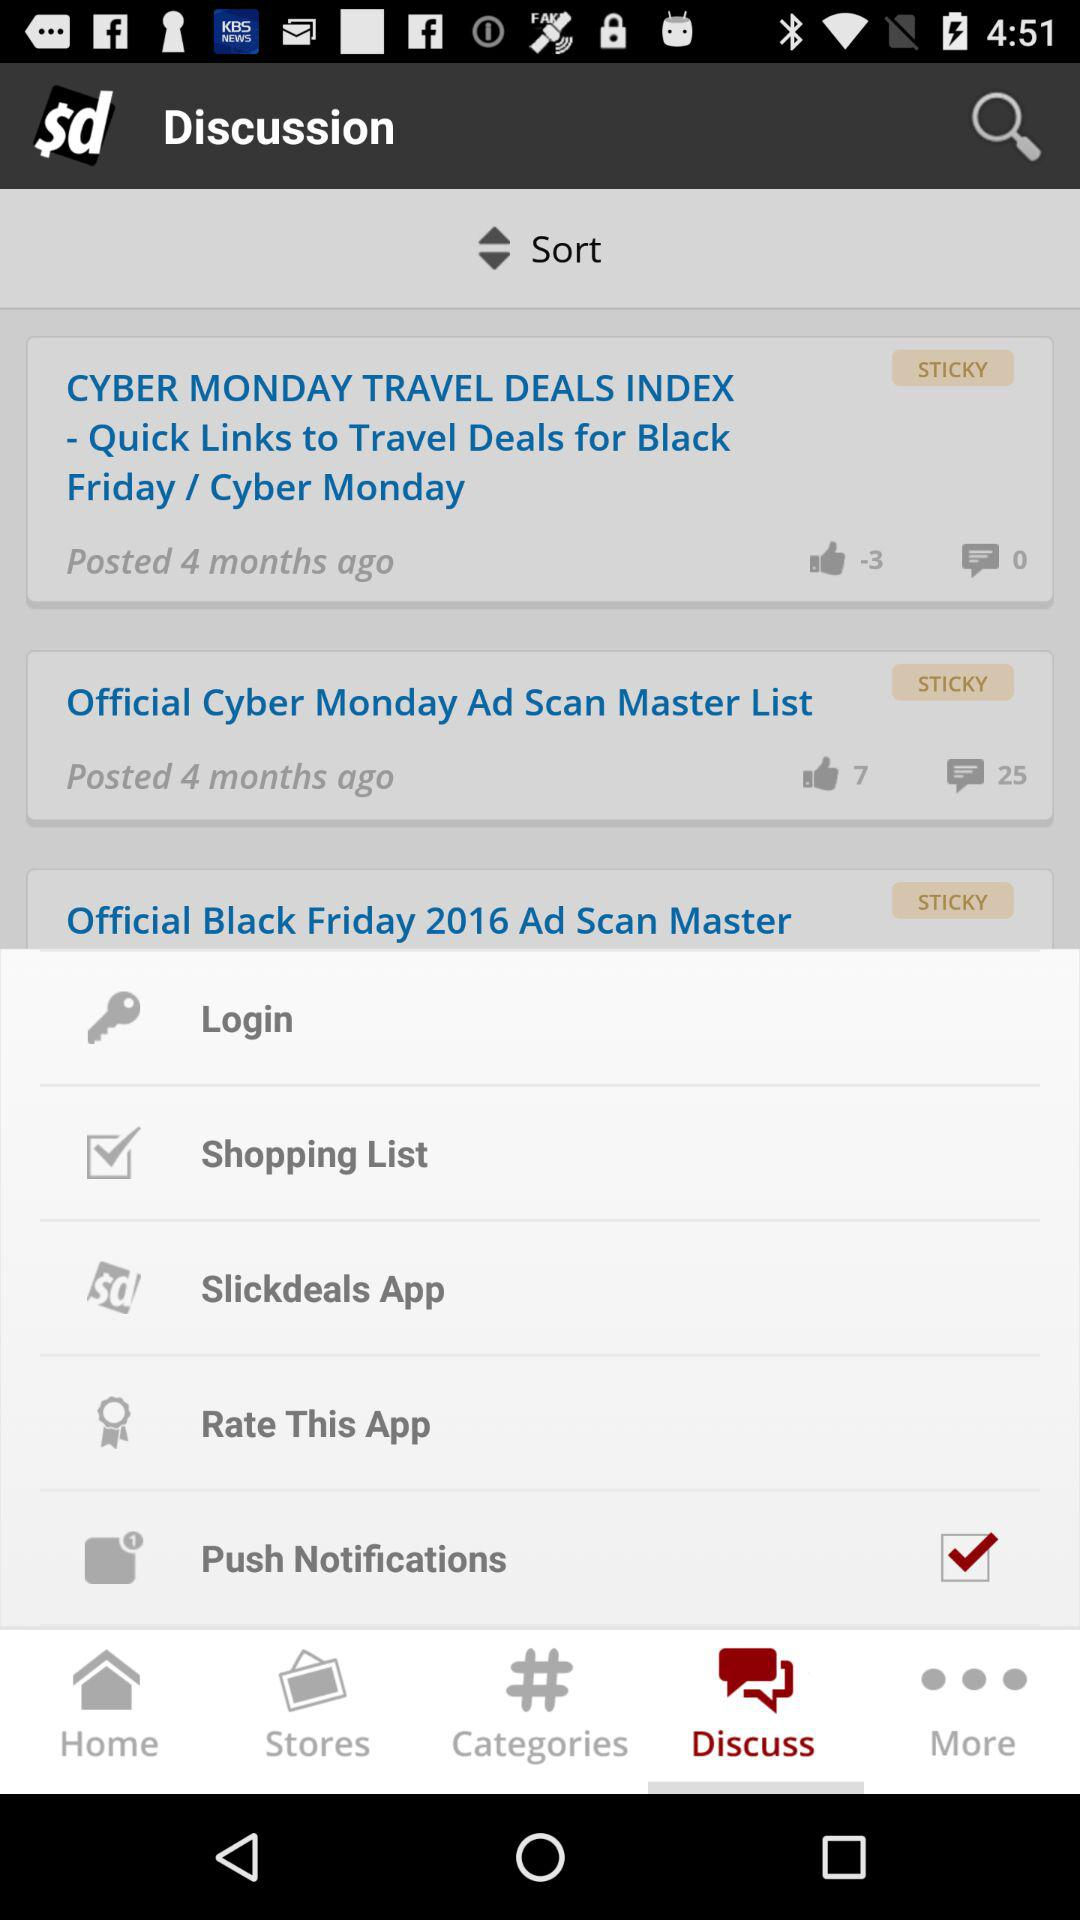How many comments are there on the "Official Cyber Monday Ad Scan Master List" post? There are 25 comments on the post. 